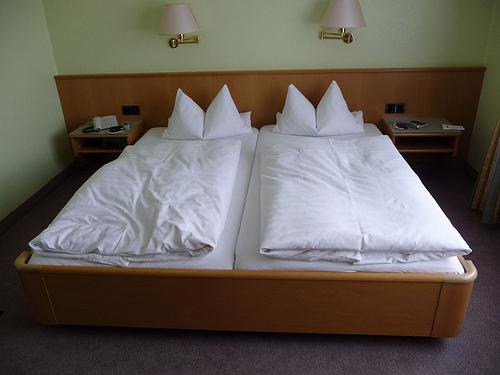Describe the arrangement of objects in the bedroom. The bedroom has a king-size bed made of wood with white sheets in the center, two nightstands with items on each side, a carpet below it, and two small lamps on the wall above it. Provide a brief description of the scene in the image. The image shows a bedroom with a king-size bed, made of wood and adorned with white sheets, pillows, and blankets, as well as two small lamps above it, and nightstands on each side. List the main objects in the image and their respective colors. Wall (off-white), bed (white, wood), pillows (white), carpet (gray, dark purple), nightstands (brown), lamps (unspecified color). Describe any minor imperfections observed in the bedding or room setup. There is a wrinkle in the duvet, a line dividing the mattresses, and a thin black line in the image. Outline the types of textiles and furniture in the image.  The image includes a wooden bed, nightstands, white sheets, pillows, and a white blanket on the bed, along with a gray and dark purple carpet on the floor. What kind of setup is observed regarding the bed in the image? The bed features two twin-size mattresses pushed together with white sheets, pillows, and blankets, as well as a wooden headboard. Mention the color of different objects observed in the image. There is an off-white wall, a white bed with white sheets and pillows, a gray carpet, a dark purple carpet below the bed, and a brown bedside table. Mention the lighting setup observed in the image. Two small lamps are mounted on the wall above the bed, providing illumination for the room. Identify the different sized beds in the image. There is a bed with two twin-sized mattresses pushed together to form a king-size bed. Remark on any unordinary object observed in the image. There is a thin black line within the image which stands out from the rest of the bedroom scene. 